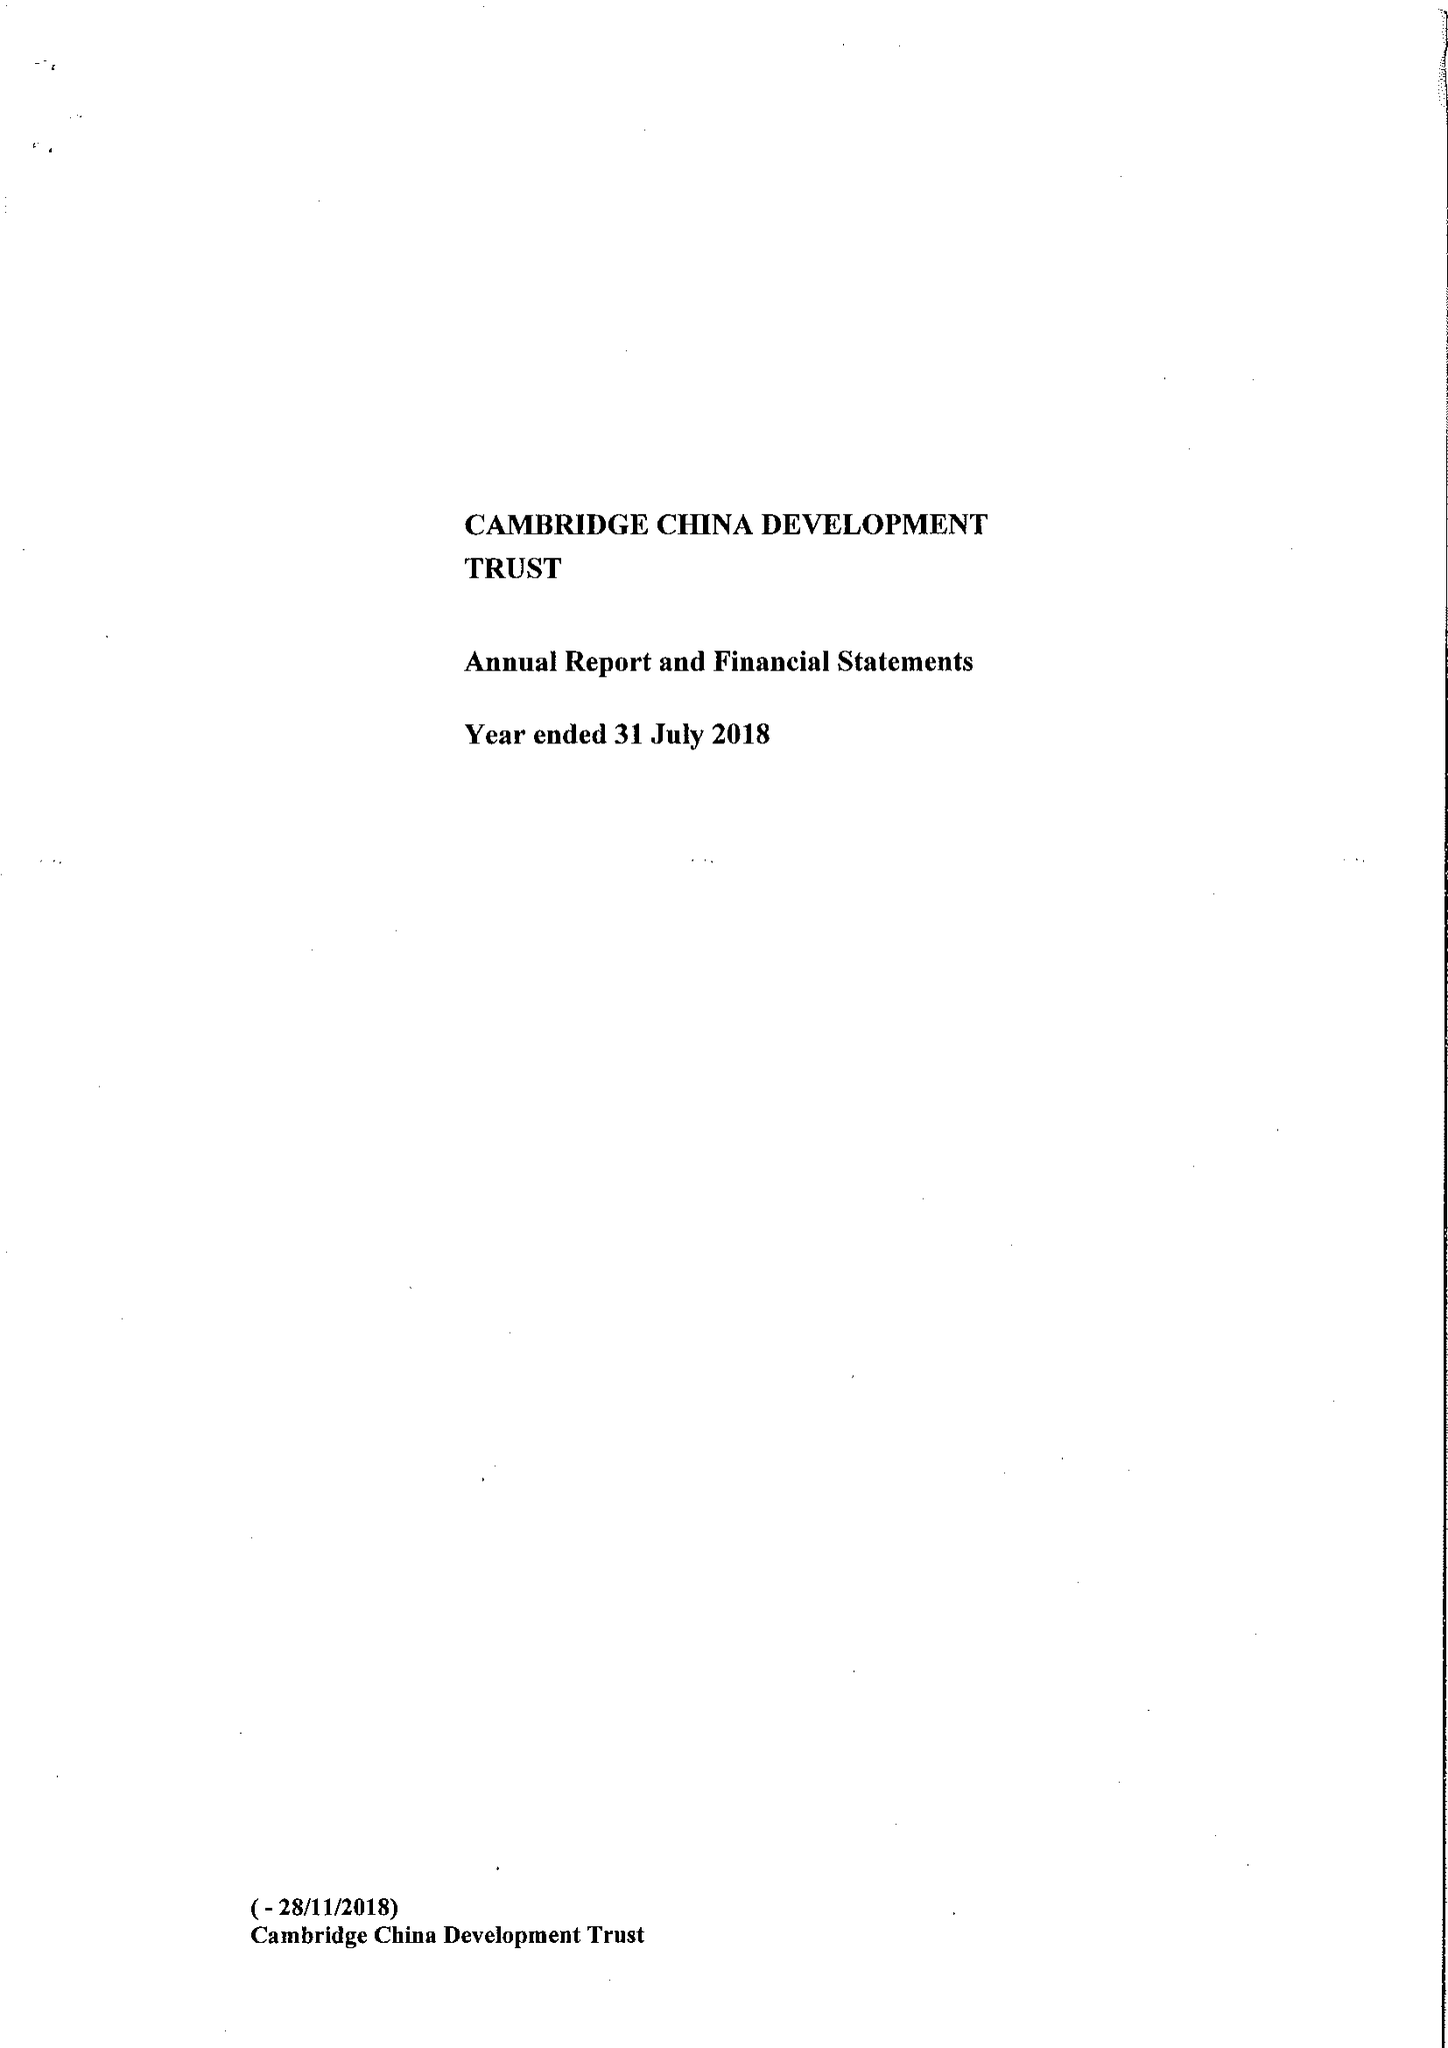What is the value for the income_annually_in_british_pounds?
Answer the question using a single word or phrase. 491165.00 